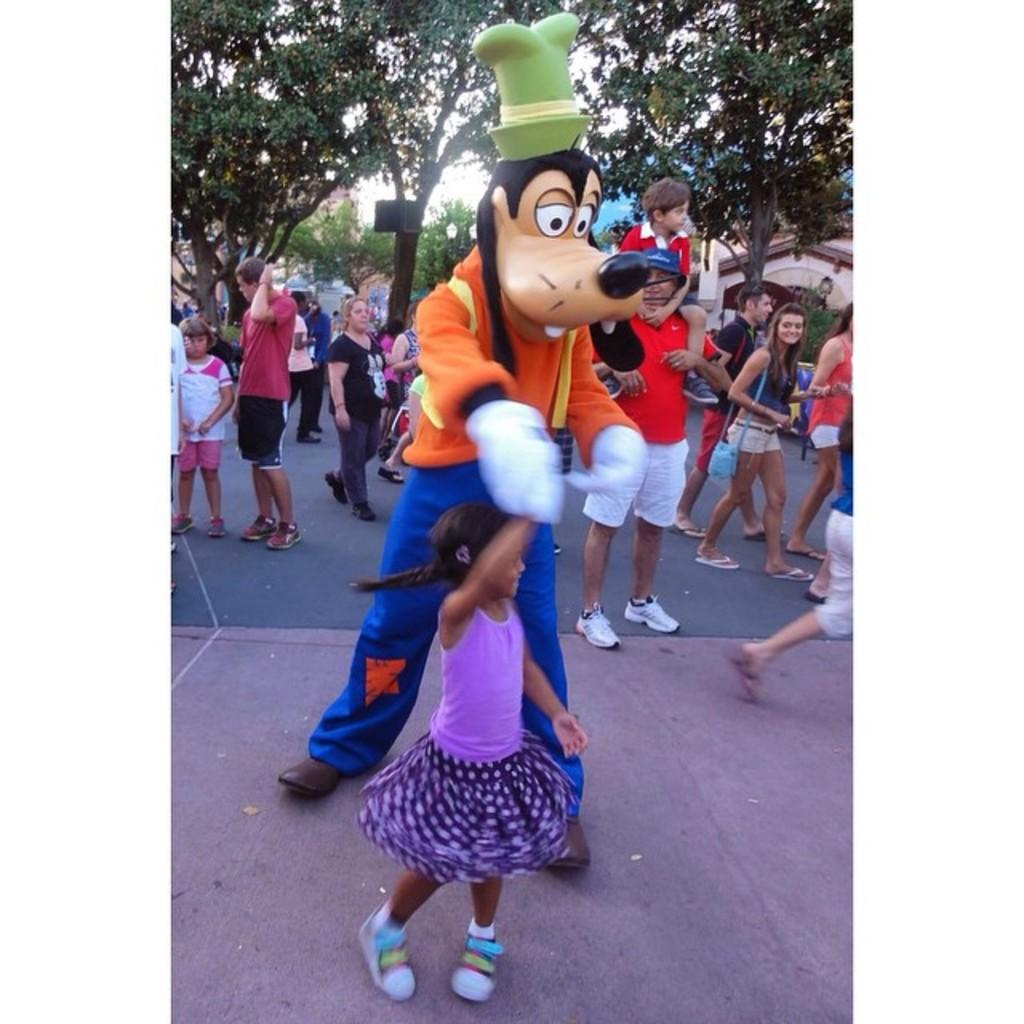What is the main subject of the image? The main subject of the image is a crowd. Can you describe any specific details about the people in the crowd? One person in the crowd is wearing a mask. What can be seen in the background of the image? There are trees in the background of the image. How does the earthquake affect the crowd in the image? There is no earthquake present in the image, so its effect on the crowd cannot be determined. 